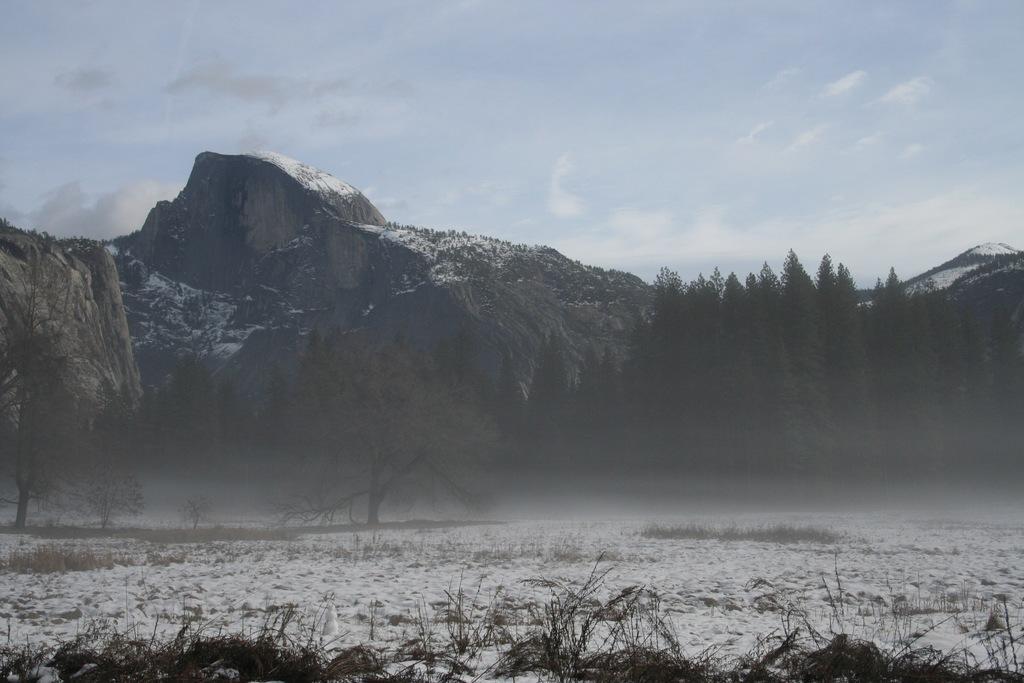Describe this image in one or two sentences. Sky is cloudy. Background there are mountains and trees. Land is covered with snow. 